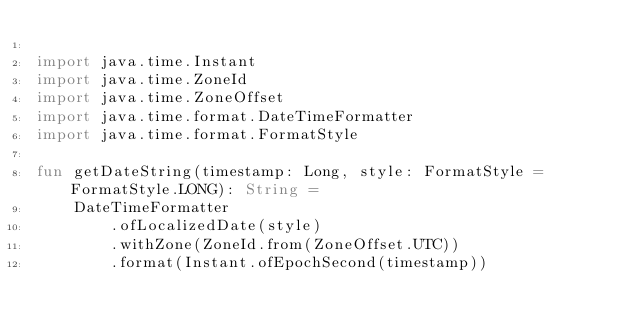Convert code to text. <code><loc_0><loc_0><loc_500><loc_500><_Kotlin_>
import java.time.Instant
import java.time.ZoneId
import java.time.ZoneOffset
import java.time.format.DateTimeFormatter
import java.time.format.FormatStyle

fun getDateString(timestamp: Long, style: FormatStyle = FormatStyle.LONG): String =
    DateTimeFormatter
        .ofLocalizedDate(style)
        .withZone(ZoneId.from(ZoneOffset.UTC))
        .format(Instant.ofEpochSecond(timestamp))
</code> 